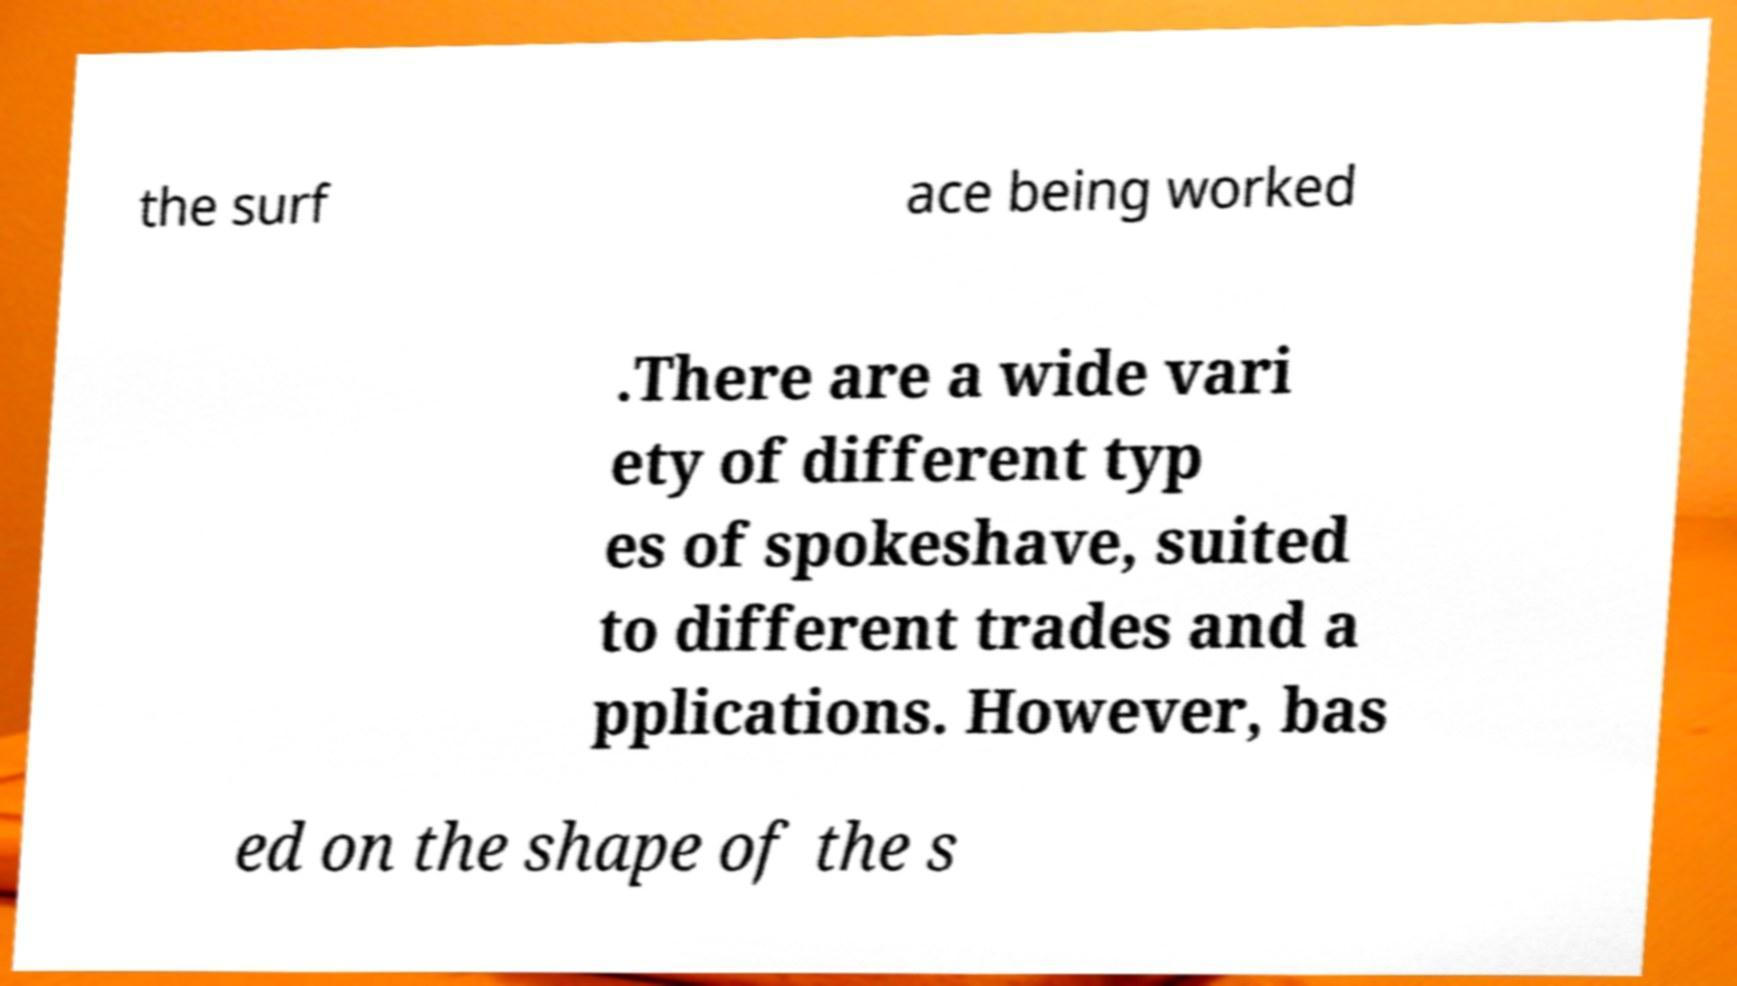What messages or text are displayed in this image? I need them in a readable, typed format. the surf ace being worked .There are a wide vari ety of different typ es of spokeshave, suited to different trades and a pplications. However, bas ed on the shape of the s 